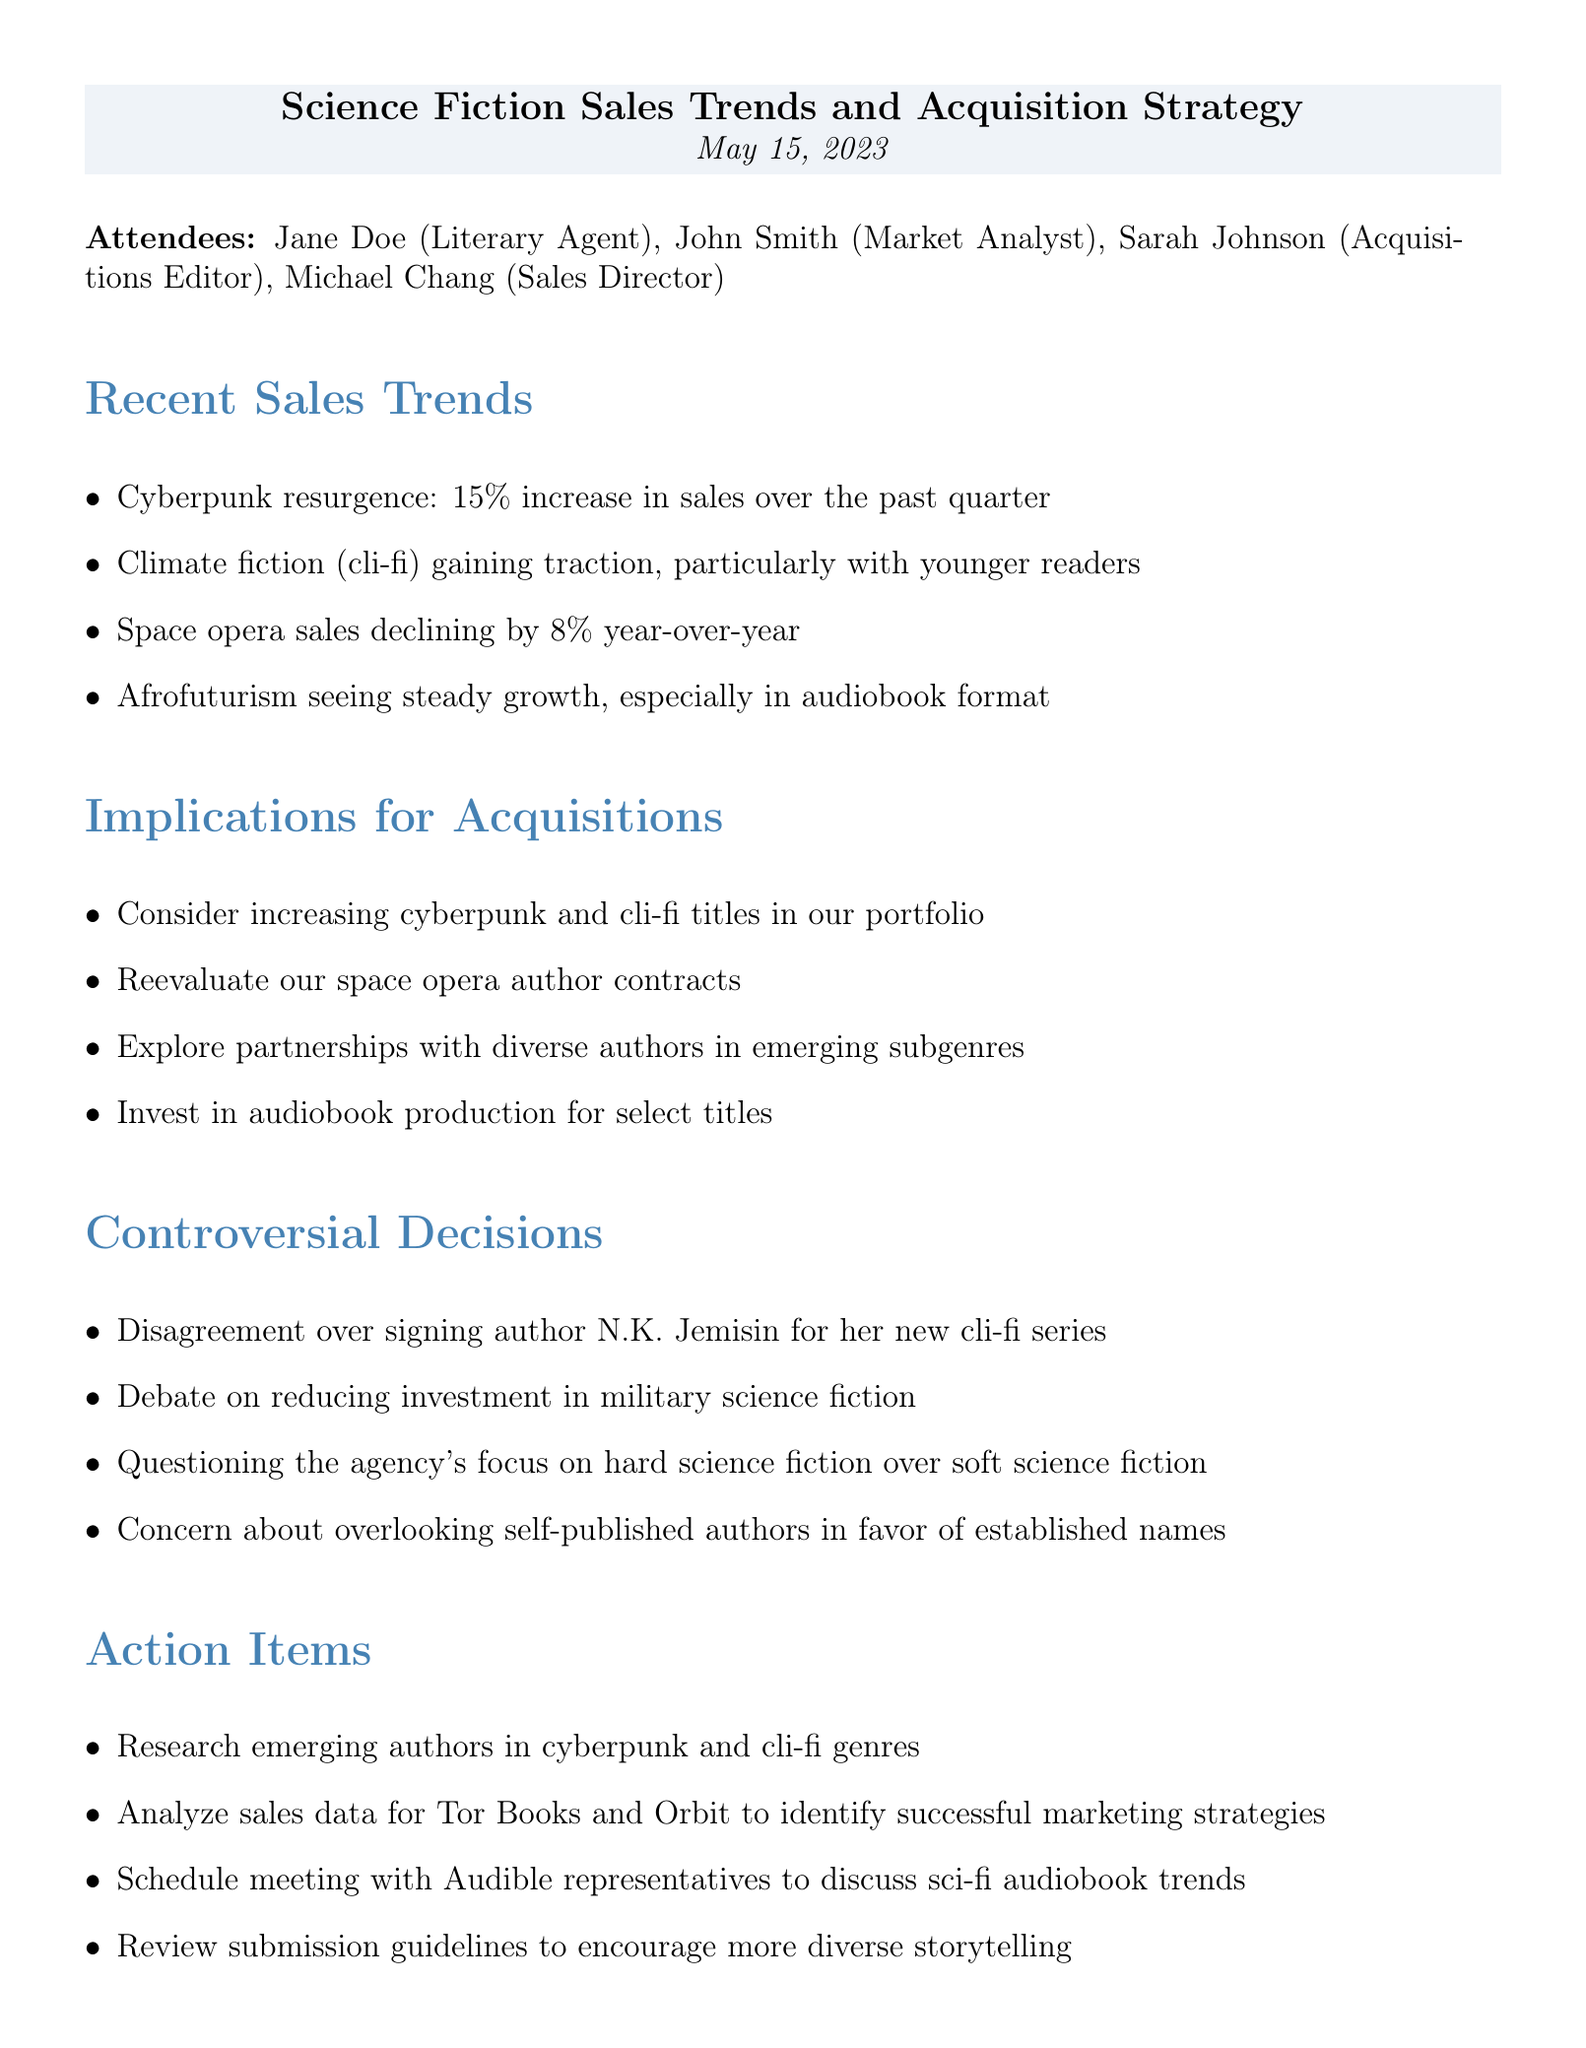What is the date of the meeting? The date of the meeting is provided in the document, specifically stated as May 15, 2023.
Answer: May 15, 2023 Who disagreed over signing N.K. Jemisin? The document mentions a disagreement regarding signing N.K. Jemisin for her new cli-fi series, indicating that there were possibly multiple individuals involved in the discussion.
Answer: N.K. Jemisin What is the percentage increase in cyberpunk sales? The document notes a 15% increase in sales for cyberpunk over the past quarter.
Answer: 15% What is the trend in space opera sales? The document specifically states that space opera sales are declining by 8% year-over-year, providing clear data on this trend.
Answer: Declining by 8% How many action items are listed in the document? The document lists four specific action items under the Action Items section, which can be easily counted.
Answer: Four What genre is particularly gaining traction with younger readers? The document refers to climate fiction (cli-fi) as gaining traction, especially among younger readers, indicating its popularity.
Answer: Climate fiction What was suggested regarding self-published authors? The document indicates a concern about overlooking self-published authors in favor of established names, pointing to a preference or bias in acquisitions.
Answer: Overlooking self-published authors When is the next meeting scheduled? The document specifies the date for the next meeting, which can be found in the concluding section about upcoming meetings.
Answer: June 15, 2023 